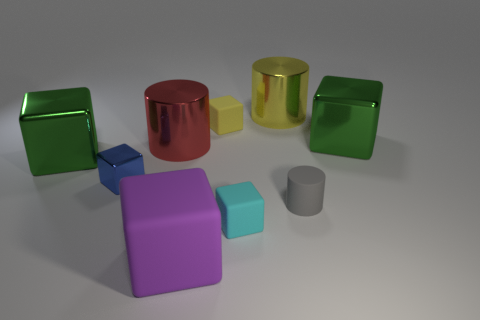Subtract all rubber cylinders. How many cylinders are left? 2 Subtract 6 cubes. How many cubes are left? 0 Add 1 blue metallic objects. How many objects exist? 10 Subtract all gray cylinders. How many cylinders are left? 2 Subtract all cylinders. How many objects are left? 6 Subtract all brown blocks. Subtract all purple balls. How many blocks are left? 6 Subtract 0 green balls. How many objects are left? 9 Subtract all yellow blocks. How many yellow cylinders are left? 1 Subtract all large yellow metallic balls. Subtract all large yellow metal cylinders. How many objects are left? 8 Add 9 tiny yellow objects. How many tiny yellow objects are left? 10 